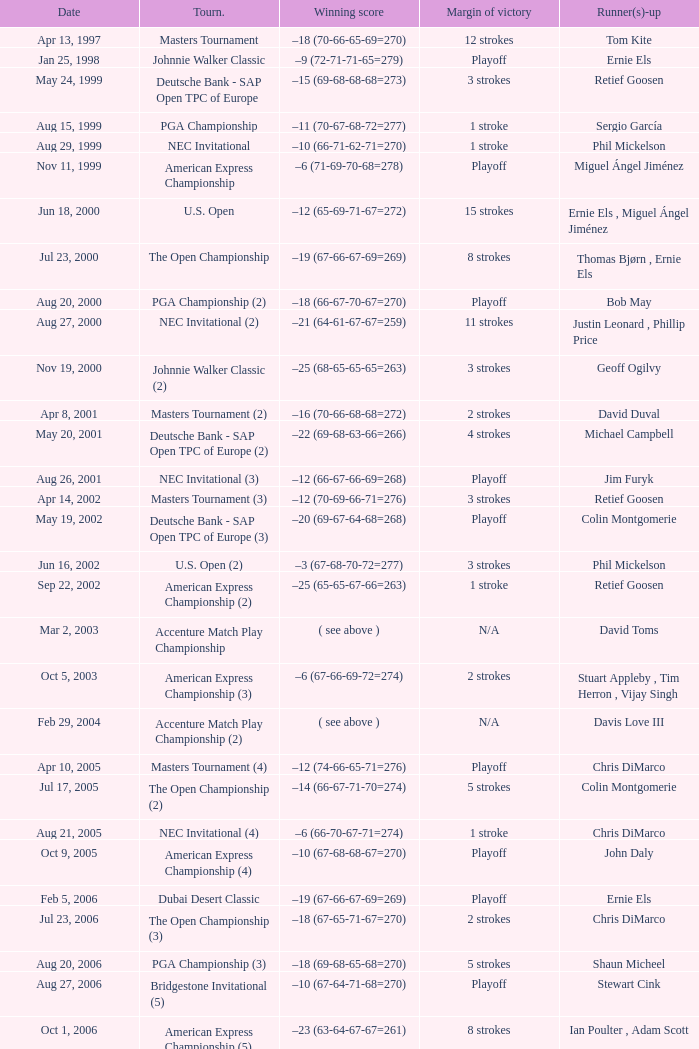Who has the Winning score of –10 (66-71-62-71=270) ? Phil Mickelson. 